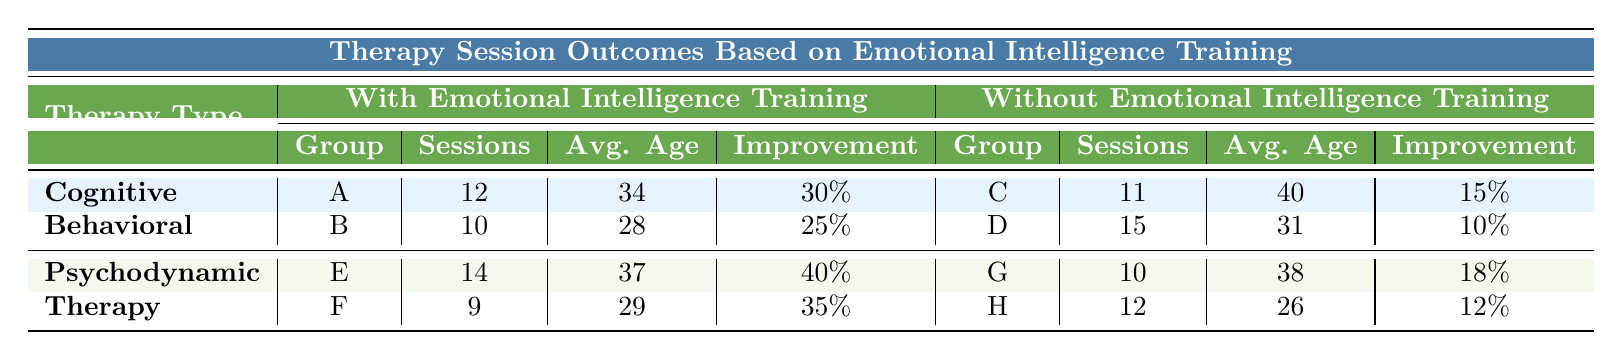What is the outcome improvement percentage for Group E? The table shows that the outcome improvement percentage for Group E (with Emotional Intelligence Training in Psychodynamic Therapy) is 40%.
Answer: 40% Which therapy type had the highest overall outcome improvement? By comparing the outcome improvements across all groups, Psychodynamic Therapy with Emotional Intelligence Training (Group E with 40% and Group F with 35%) has the highest outcome improvement at 40%.
Answer: Psychodynamic Therapy What is the average age of participants in Group C? The table provides the average age of participants in Group C (without Emotional Intelligence Training in Cognitive Behavioral Therapy) as 40 years.
Answer: 40 How many sessions did Group A have compared to Group D? Group A had 12 sessions, whereas Group D had 15 sessions. The difference is 15 - 12 = 3 sessions.
Answer: 3 sessions What was the average number of sessions for the groups without Emotional Intelligence Training? The average number of sessions can be calculated by summing sessions of Group C (11), Group D (15), Group G (10), and Group H (12), which totals 48 sessions divided by 4 groups, resulting in an average of 12 sessions.
Answer: 12 Did any of the groups with Emotional Intelligence Training have an outcome improvement below 30%? No, all groups with Emotional Intelligence Training (Group A with 30%, Group E with 40%, and Group F with 35%) had improvements above 30%.
Answer: No Which group had the lowest outcome improvement overall, and what was the percentage? Group D, which had no Emotional Intelligence Training, had the lowest outcome improvement at 10%.
Answer: Group D, 10% What is the total outcome improvement for all groups with Emotional Intelligence Training? Summing the outcome improvements: Group A (30%) + Group E (40%) + Group F (35%) = 105%.
Answer: 105% What is the gender distribution for Group F? Referring to the table, Group F has 55 males and 45 females.
Answer: 55 males, 45 females Which group had the highest average age among those without Emotional Intelligence Training? Group G had the highest average age at 38 years, compared to Group D's 31 and Group H's 26.
Answer: Group G, 38 years old 